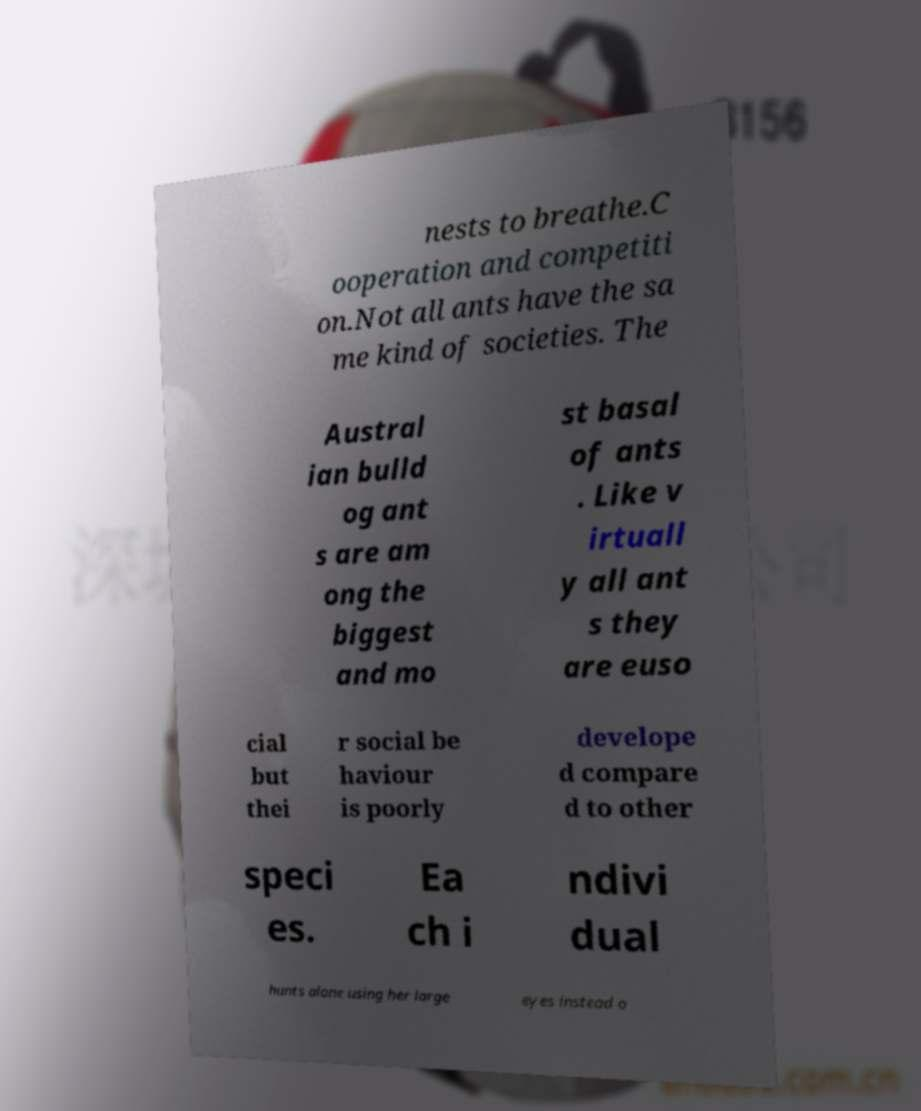Please read and relay the text visible in this image. What does it say? nests to breathe.C ooperation and competiti on.Not all ants have the sa me kind of societies. The Austral ian bulld og ant s are am ong the biggest and mo st basal of ants . Like v irtuall y all ant s they are euso cial but thei r social be haviour is poorly develope d compare d to other speci es. Ea ch i ndivi dual hunts alone using her large eyes instead o 